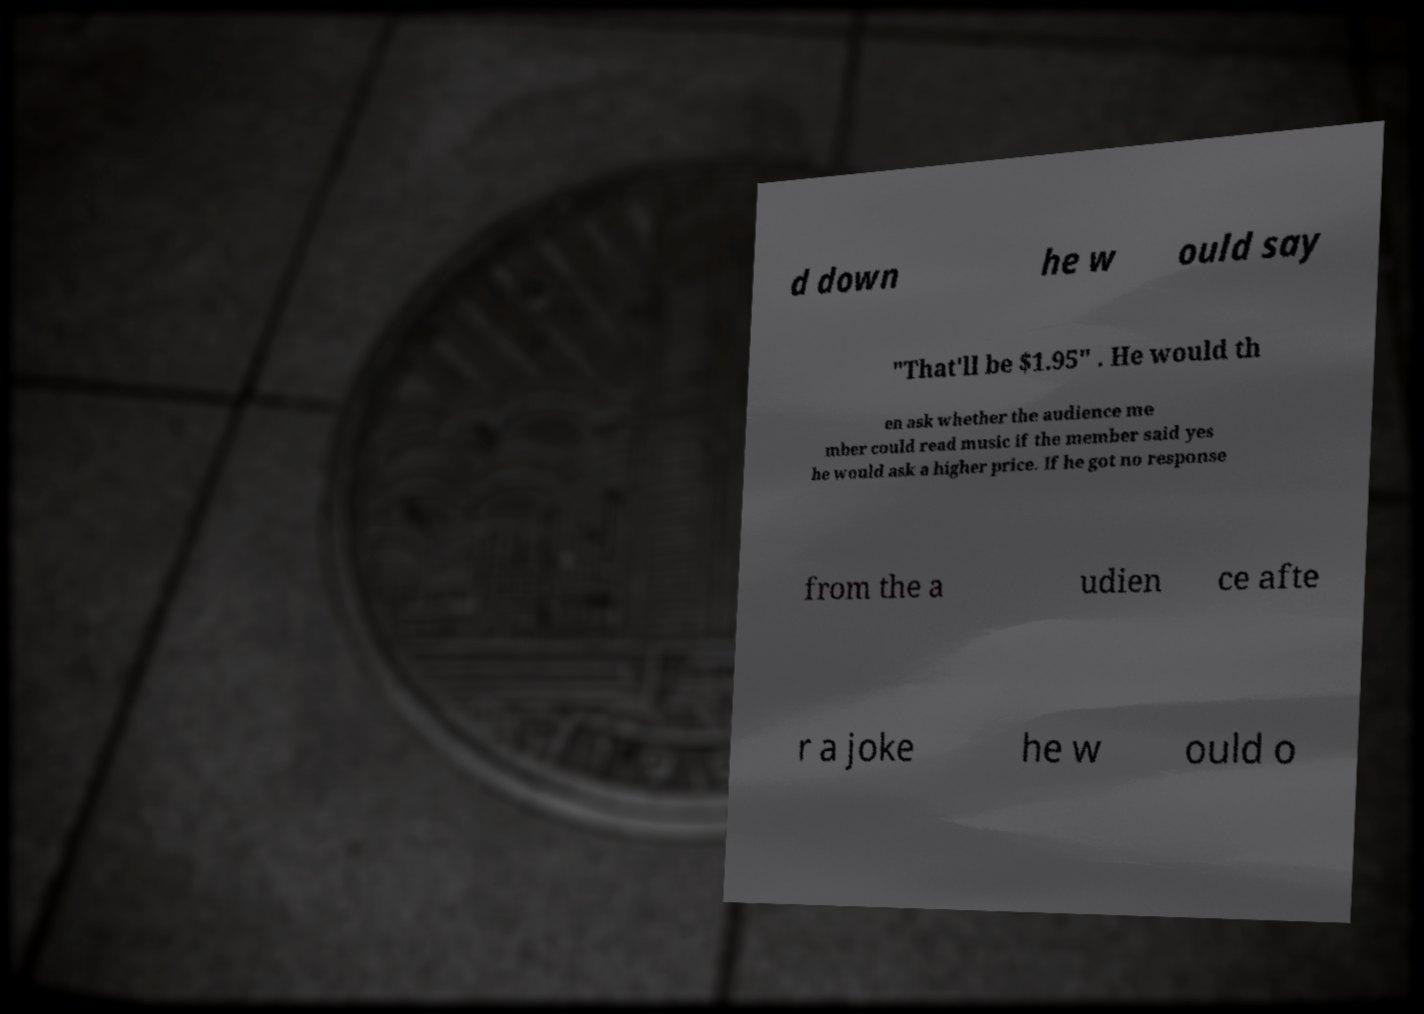Could you assist in decoding the text presented in this image and type it out clearly? d down he w ould say "That'll be $1.95" . He would th en ask whether the audience me mber could read music if the member said yes he would ask a higher price. If he got no response from the a udien ce afte r a joke he w ould o 